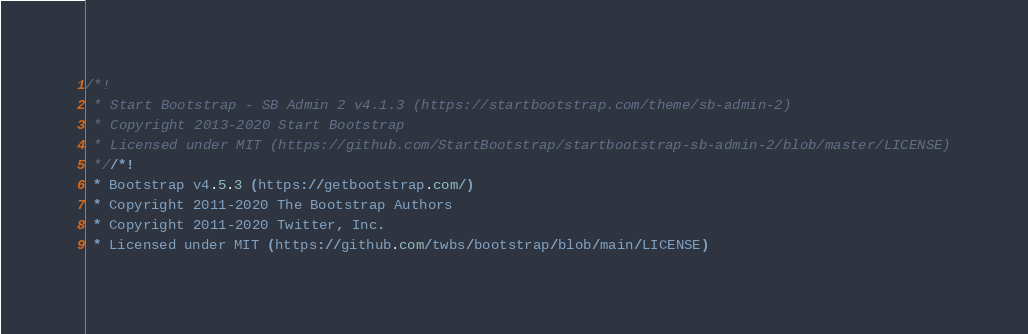<code> <loc_0><loc_0><loc_500><loc_500><_CSS_>/*!
 * Start Bootstrap - SB Admin 2 v4.1.3 (https://startbootstrap.com/theme/sb-admin-2)
 * Copyright 2013-2020 Start Bootstrap
 * Licensed under MIT (https://github.com/StartBootstrap/startbootstrap-sb-admin-2/blob/master/LICENSE)
 *//*!
 * Bootstrap v4.5.3 (https://getbootstrap.com/)
 * Copyright 2011-2020 The Bootstrap Authors
 * Copyright 2011-2020 Twitter, Inc.
 * Licensed under MIT (https://github.com/twbs/bootstrap/blob/main/LICENSE)</code> 